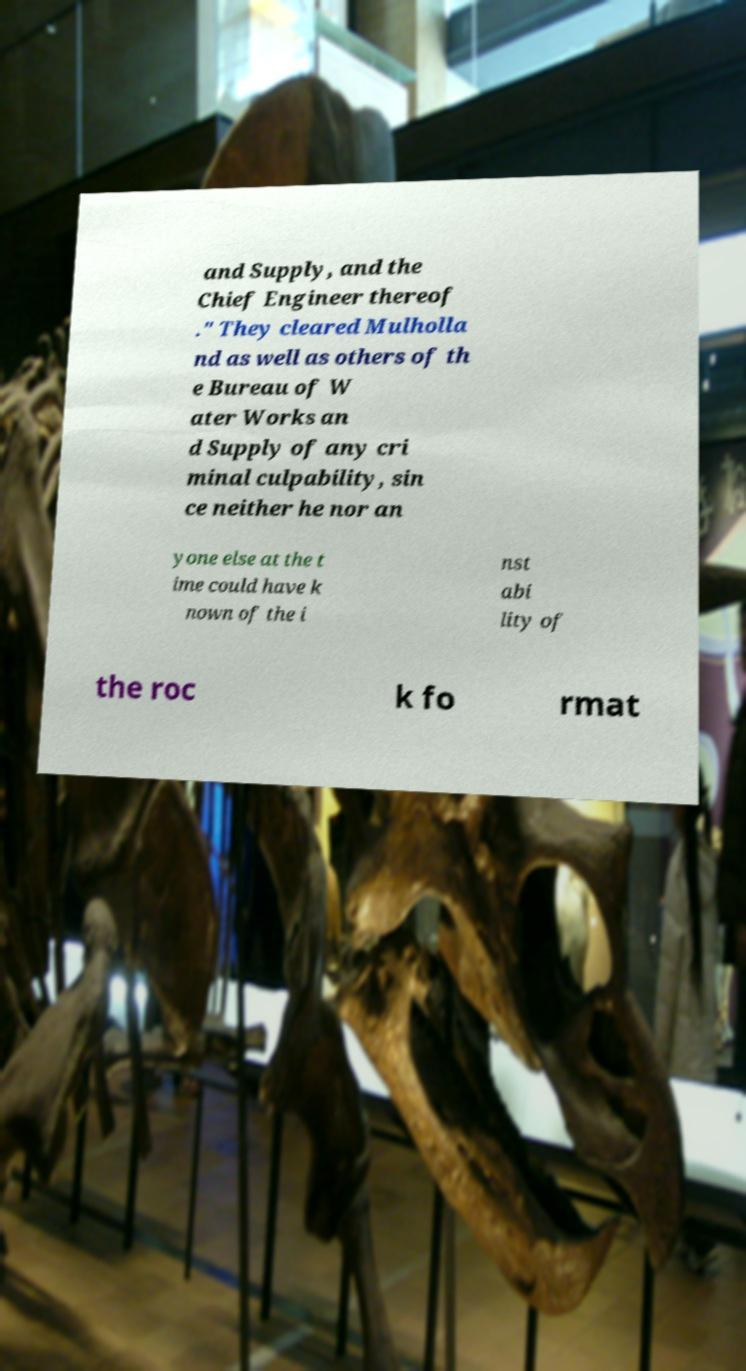For documentation purposes, I need the text within this image transcribed. Could you provide that? and Supply, and the Chief Engineer thereof ." They cleared Mulholla nd as well as others of th e Bureau of W ater Works an d Supply of any cri minal culpability, sin ce neither he nor an yone else at the t ime could have k nown of the i nst abi lity of the roc k fo rmat 